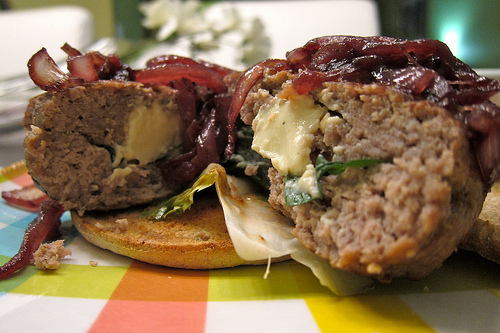<image>
Is the meat on the table? Yes. Looking at the image, I can see the meat is positioned on top of the table, with the table providing support. 